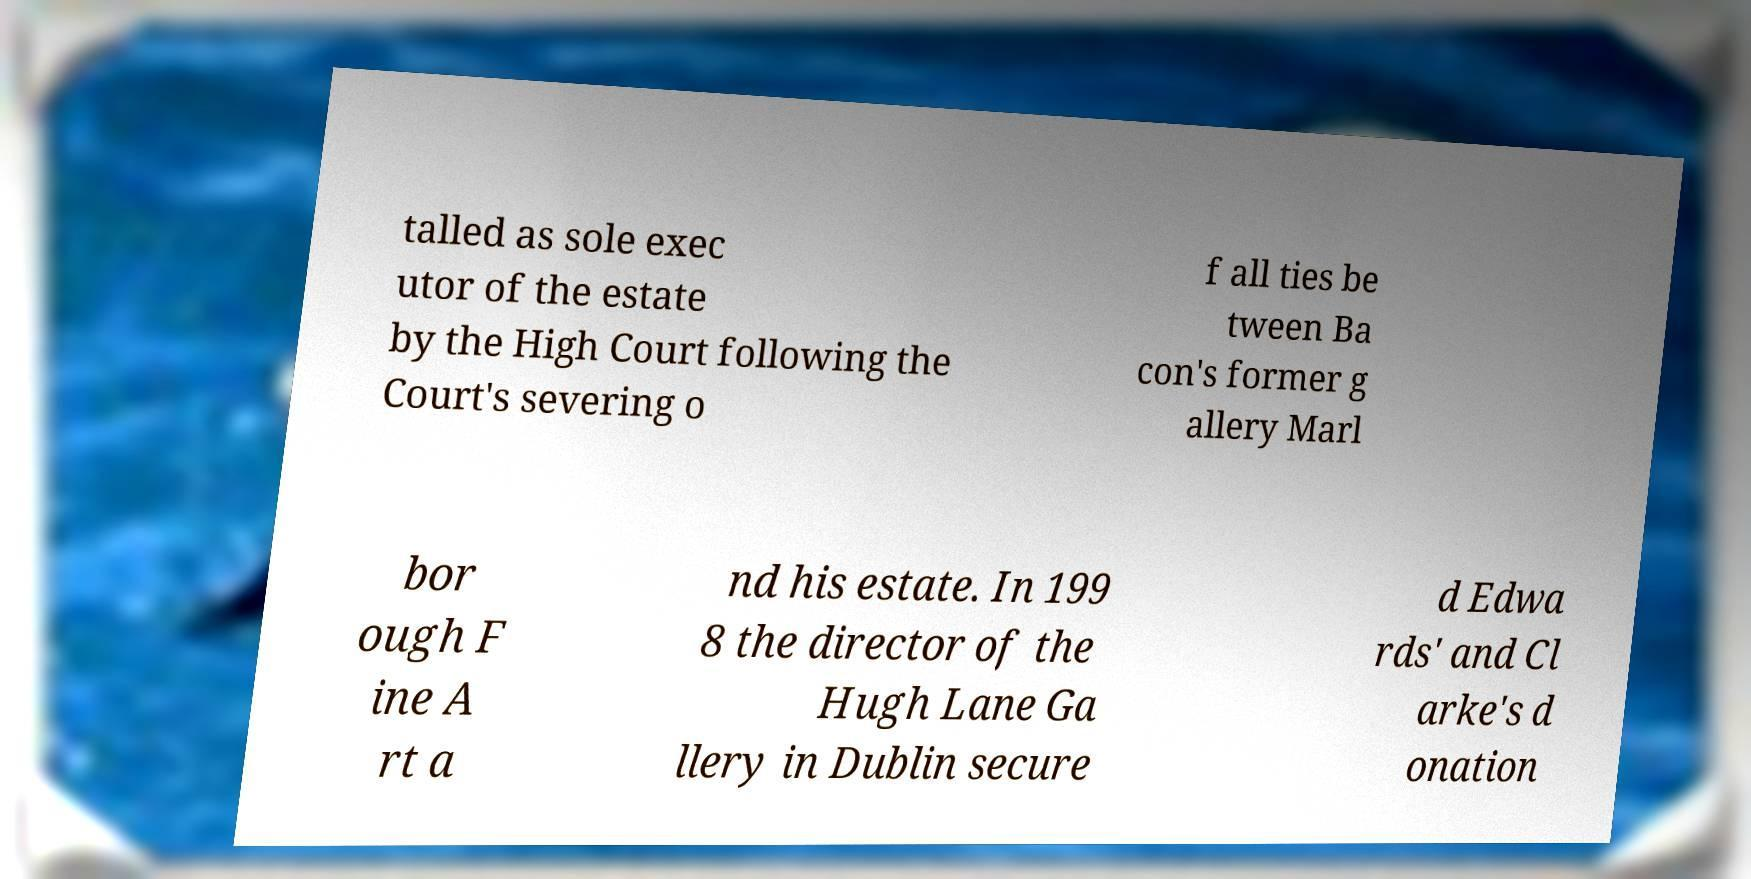I need the written content from this picture converted into text. Can you do that? talled as sole exec utor of the estate by the High Court following the Court's severing o f all ties be tween Ba con's former g allery Marl bor ough F ine A rt a nd his estate. In 199 8 the director of the Hugh Lane Ga llery in Dublin secure d Edwa rds' and Cl arke's d onation 